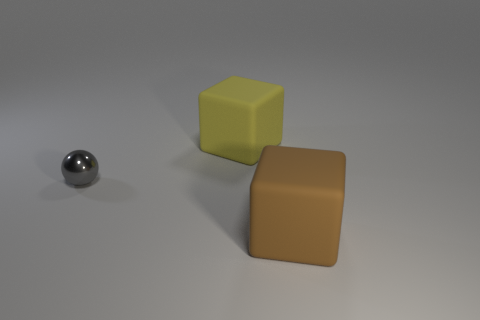Add 1 big yellow objects. How many objects exist? 4 Subtract 1 balls. How many balls are left? 0 Subtract all blocks. How many objects are left? 1 Subtract all purple cubes. Subtract all yellow cylinders. How many cubes are left? 2 Subtract all large things. Subtract all brown matte blocks. How many objects are left? 0 Add 2 tiny spheres. How many tiny spheres are left? 3 Add 3 brown matte things. How many brown matte things exist? 4 Subtract 0 yellow balls. How many objects are left? 3 